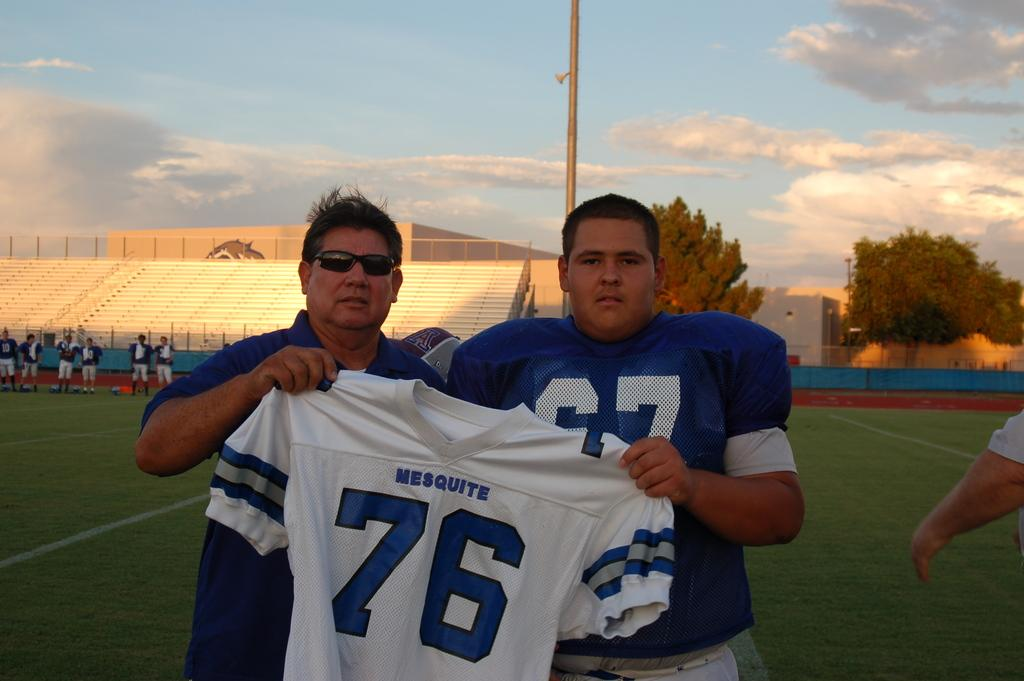<image>
Provide a brief description of the given image. Two men hold up a white sports top with mesquite and 76 on it. 